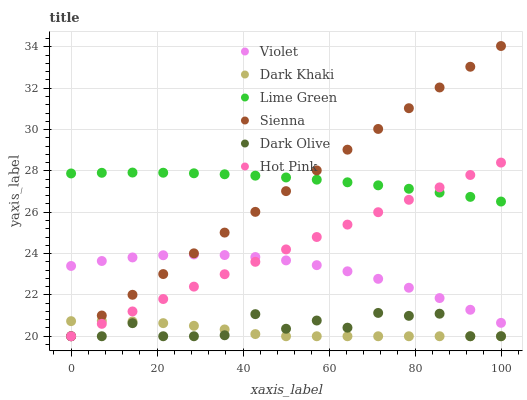Does Dark Khaki have the minimum area under the curve?
Answer yes or no. Yes. Does Lime Green have the maximum area under the curve?
Answer yes or no. Yes. Does Dark Olive have the minimum area under the curve?
Answer yes or no. No. Does Dark Olive have the maximum area under the curve?
Answer yes or no. No. Is Hot Pink the smoothest?
Answer yes or no. Yes. Is Dark Olive the roughest?
Answer yes or no. Yes. Is Dark Olive the smoothest?
Answer yes or no. No. Is Hot Pink the roughest?
Answer yes or no. No. Does Sienna have the lowest value?
Answer yes or no. Yes. Does Violet have the lowest value?
Answer yes or no. No. Does Sienna have the highest value?
Answer yes or no. Yes. Does Dark Olive have the highest value?
Answer yes or no. No. Is Dark Khaki less than Lime Green?
Answer yes or no. Yes. Is Lime Green greater than Violet?
Answer yes or no. Yes. Does Violet intersect Hot Pink?
Answer yes or no. Yes. Is Violet less than Hot Pink?
Answer yes or no. No. Is Violet greater than Hot Pink?
Answer yes or no. No. Does Dark Khaki intersect Lime Green?
Answer yes or no. No. 